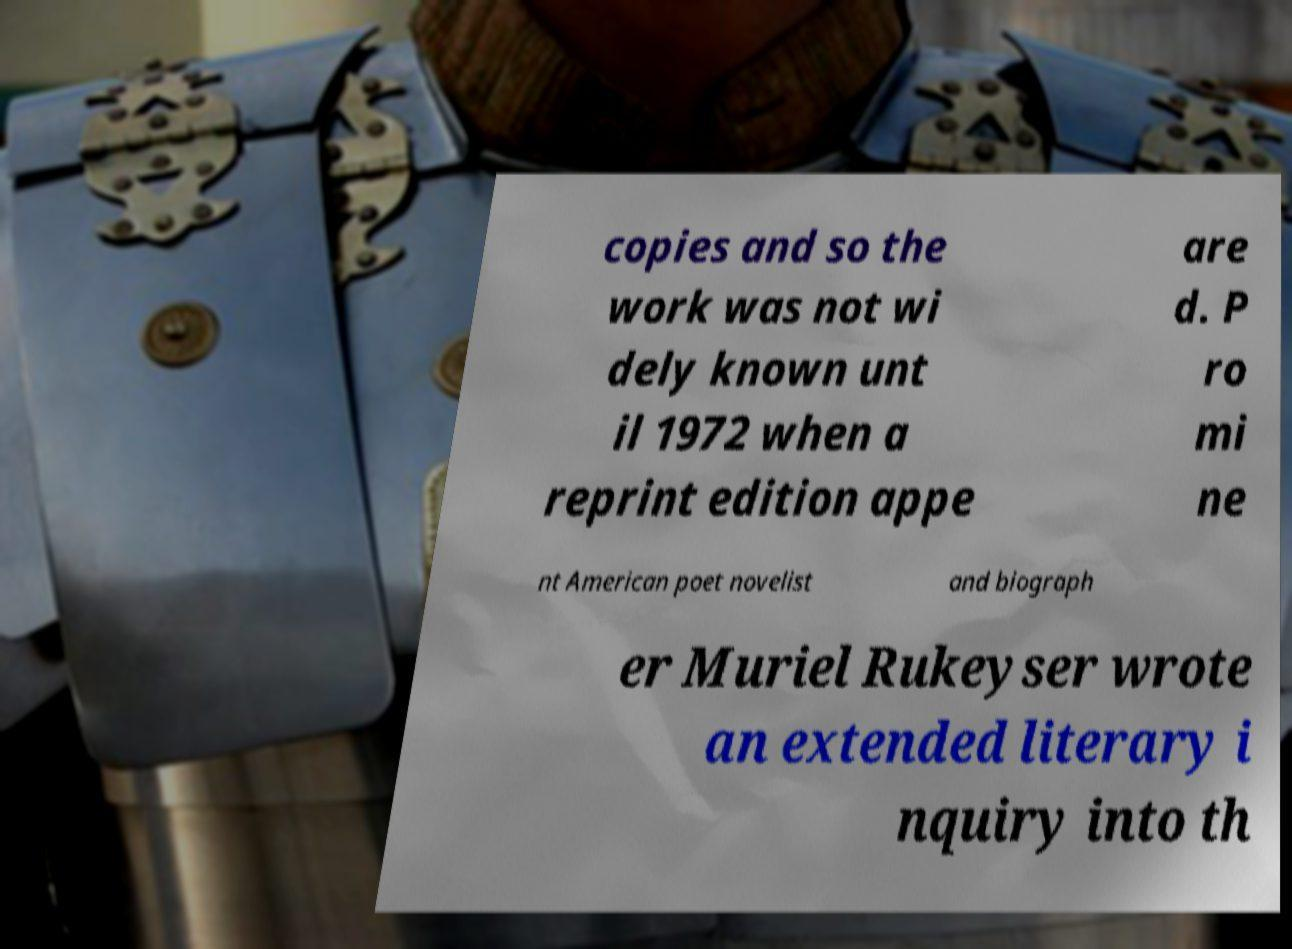Please identify and transcribe the text found in this image. copies and so the work was not wi dely known unt il 1972 when a reprint edition appe are d. P ro mi ne nt American poet novelist and biograph er Muriel Rukeyser wrote an extended literary i nquiry into th 